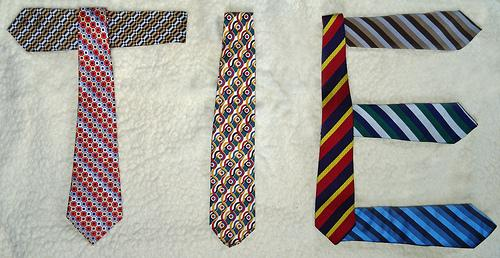How many ties are shown in the photograph? Seven ties are shown in the photo. What type of material is covering the display in the image? A cotton white blanket is covering the display in the image. What is the sentiment associated with seeing multiple ties of different colors and patterns in the image? The sentiment associated can be positive, as the image displays a variety of ties showcasing diverse styles and colors. Describe the pattern on the red, white, and blue tie. The red, white, and blue tie has polka dots. Assess the overall image quality considering the provided image and positions of the objects. The overall image quality appears to be satisfactory, as the image and positions provide clear information on the objects within the image. Are there any letters depicted in the image? If yes, which ones? Yes, the letters "t", "i", and "e" are depicted in the image, spelling the word "tie." Identify the two primary colors on the tie with a "t" sign. The tie with the "t" sign is brown and white. Which tie stands alone in the picture? The tie with green, yellow, red, and white designs stands alone in the picture. What is the primary difference between the green and blue striped tie and the blue and black striped tie? The primary difference is the color, where one has green and blue stripes, and the other has blue and black stripes, respectively. 